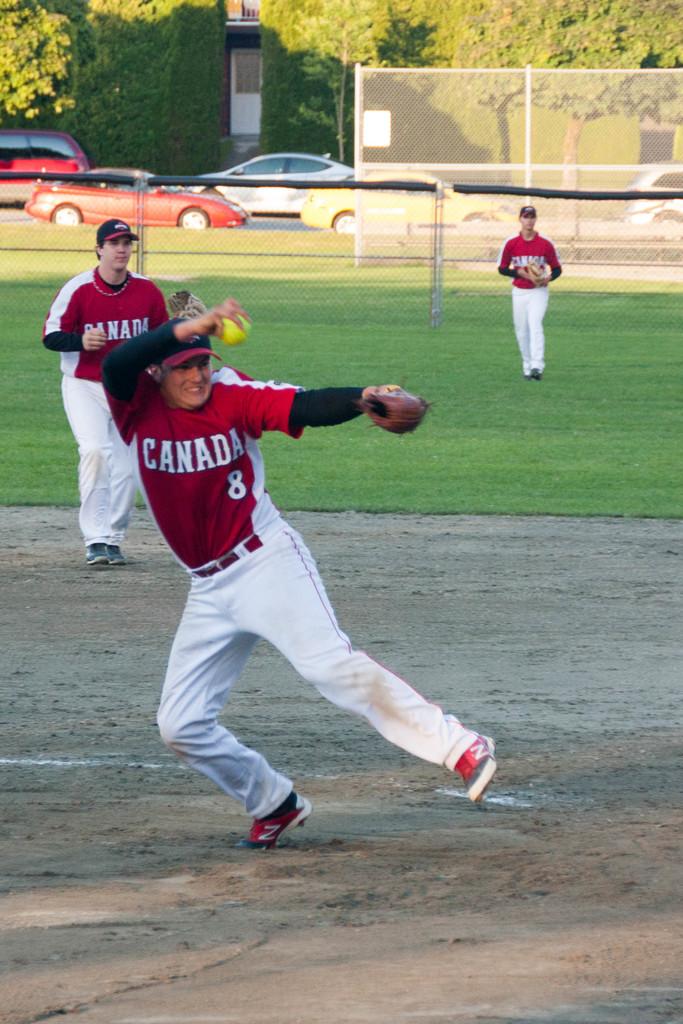What country name is mentioned on the jersey?
Keep it short and to the point. Canada. 